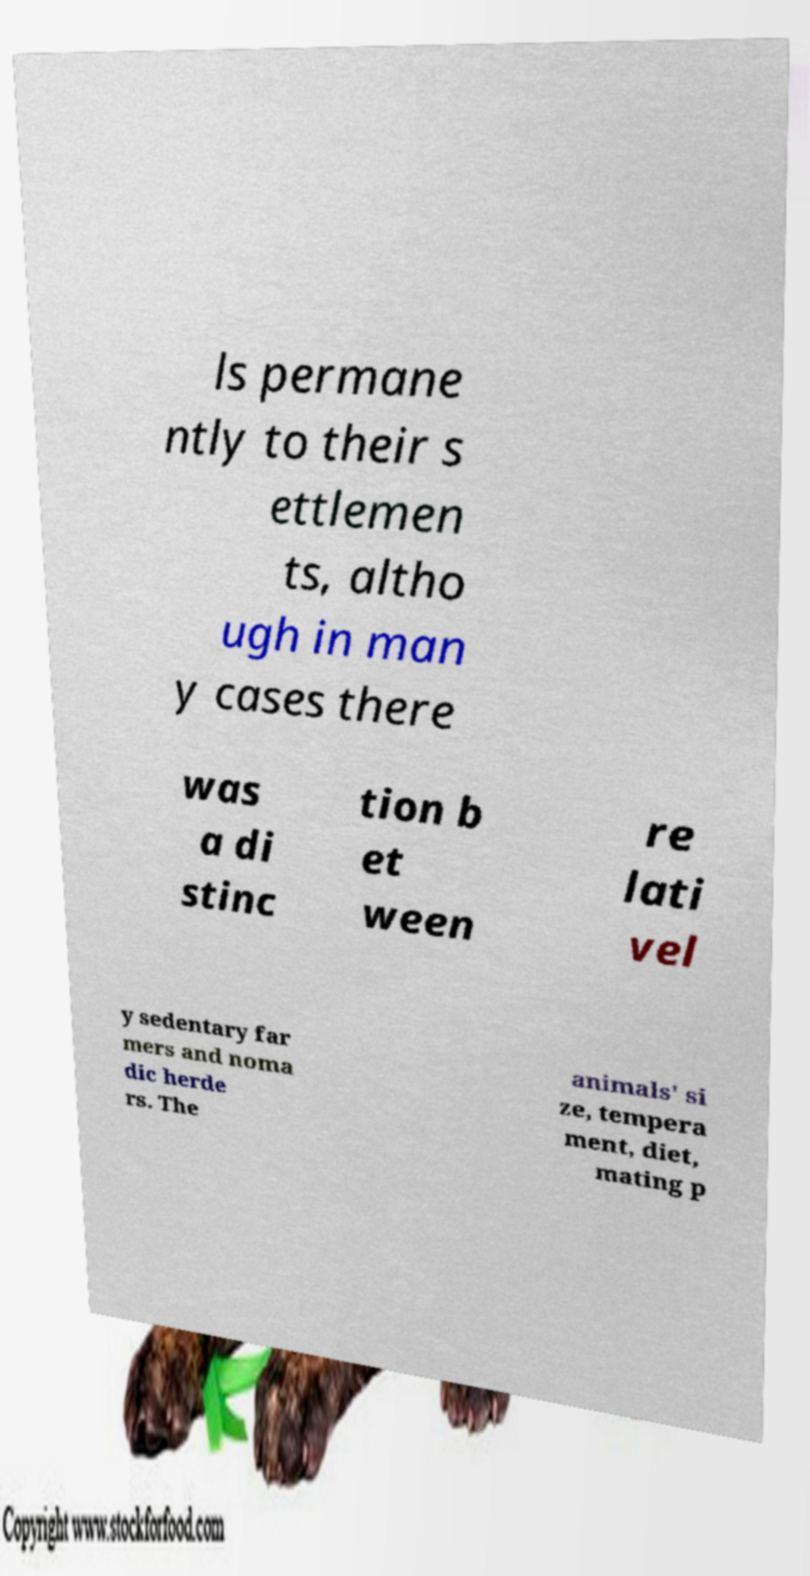Can you accurately transcribe the text from the provided image for me? ls permane ntly to their s ettlemen ts, altho ugh in man y cases there was a di stinc tion b et ween re lati vel y sedentary far mers and noma dic herde rs. The animals' si ze, tempera ment, diet, mating p 